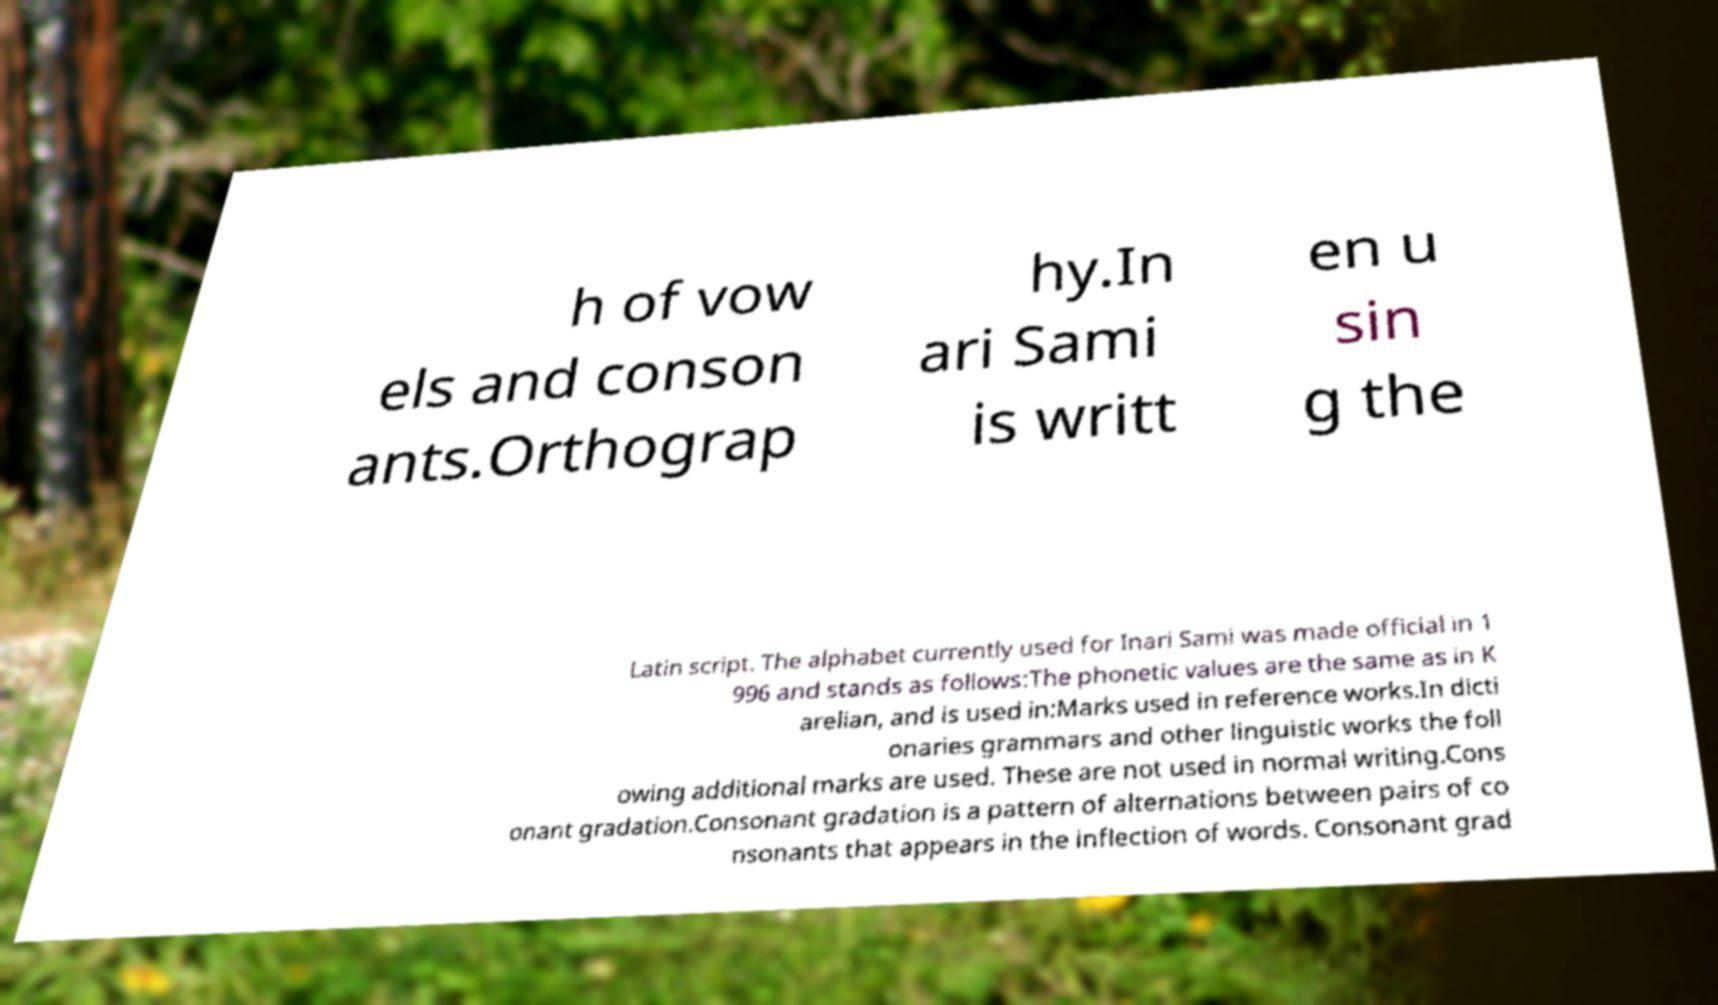What messages or text are displayed in this image? I need them in a readable, typed format. h of vow els and conson ants.Orthograp hy.In ari Sami is writt en u sin g the Latin script. The alphabet currently used for Inari Sami was made official in 1 996 and stands as follows:The phonetic values are the same as in K arelian, and is used in:Marks used in reference works.In dicti onaries grammars and other linguistic works the foll owing additional marks are used. These are not used in normal writing.Cons onant gradation.Consonant gradation is a pattern of alternations between pairs of co nsonants that appears in the inflection of words. Consonant grad 